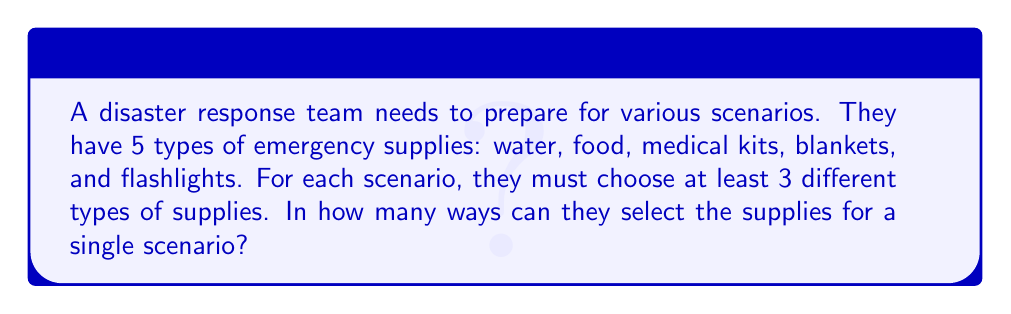Can you solve this math problem? Let's approach this step-by-step using combinatorics:

1) We need to consider all possible combinations of 3, 4, or 5 types of supplies.

2) For 3 types of supplies:
   We use the combination formula: $\binom{5}{3} = \frac{5!}{3!(5-3)!} = 10$

3) For 4 types of supplies:
   $\binom{5}{4} = \frac{5!}{4!(5-4)!} = 5$

4) For 5 types of supplies:
   $\binom{5}{5} = \frac{5!}{5!(5-5)!} = 1$

5) The total number of ways is the sum of all these combinations:

   $$\binom{5}{3} + \binom{5}{4} + \binom{5}{5} = 10 + 5 + 1 = 16$$

Therefore, there are 16 different ways to select the supplies for a single scenario.
Answer: 16 